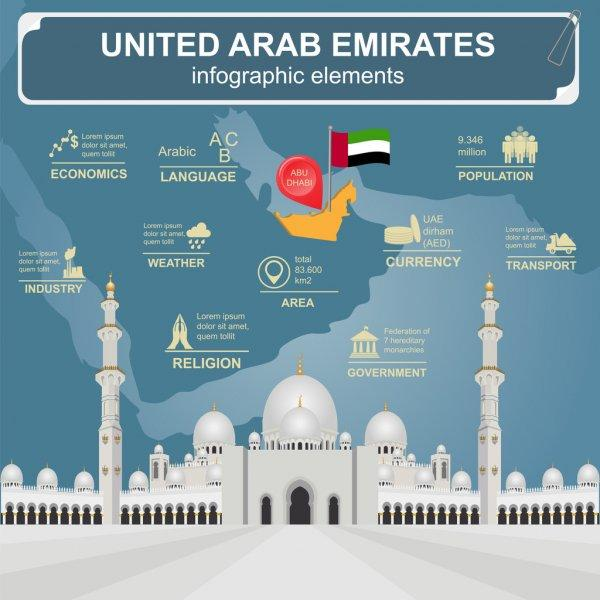Mention a couple of crucial points in this snapshot. The population of the United Arab Emirates is approximately 9.436 million people. The capital of the United Arab Emirates is Abu Dhabi. The total area of the United Arab Emirates is 83,600 km2. The official currency of the United Arab Emirates is the UAE Dirham (AED). The official language in the United Arab Emirates is Arabic. 